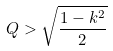<formula> <loc_0><loc_0><loc_500><loc_500>Q > \sqrt { \frac { 1 - k ^ { 2 } } { 2 } }</formula> 